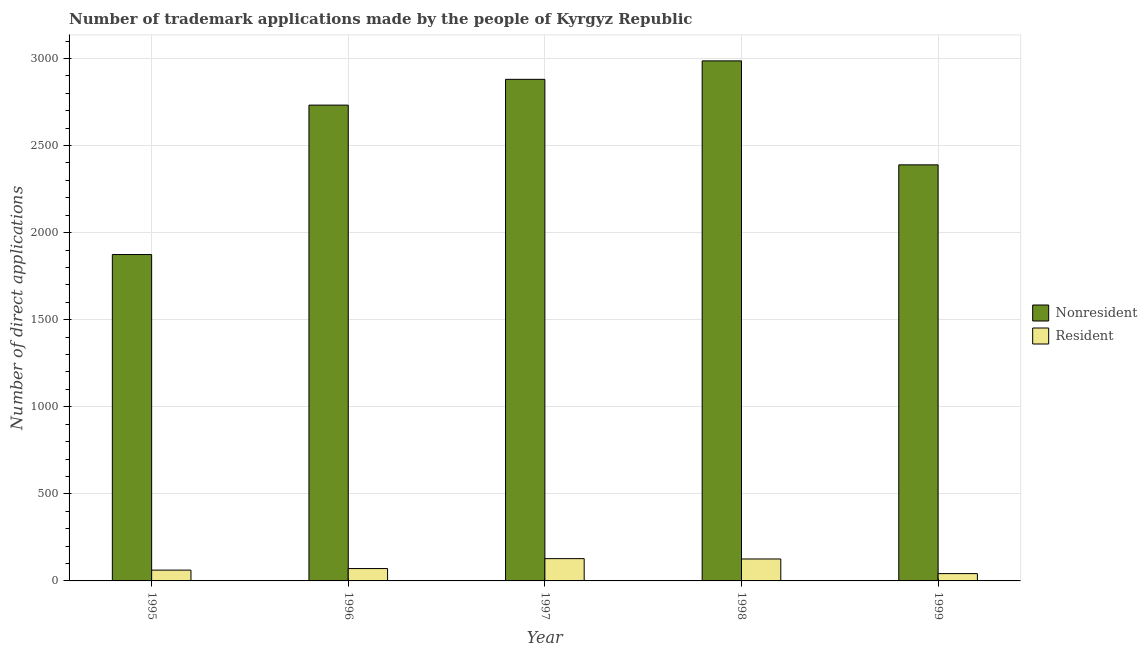Are the number of bars per tick equal to the number of legend labels?
Your answer should be compact. Yes. Are the number of bars on each tick of the X-axis equal?
Give a very brief answer. Yes. How many bars are there on the 2nd tick from the left?
Make the answer very short. 2. How many bars are there on the 2nd tick from the right?
Your answer should be very brief. 2. What is the label of the 5th group of bars from the left?
Give a very brief answer. 1999. What is the number of trademark applications made by residents in 1999?
Your answer should be compact. 42. Across all years, what is the maximum number of trademark applications made by residents?
Your answer should be compact. 128. Across all years, what is the minimum number of trademark applications made by non residents?
Offer a terse response. 1874. In which year was the number of trademark applications made by residents maximum?
Make the answer very short. 1997. In which year was the number of trademark applications made by non residents minimum?
Your answer should be very brief. 1995. What is the total number of trademark applications made by non residents in the graph?
Give a very brief answer. 1.29e+04. What is the difference between the number of trademark applications made by residents in 1995 and that in 1996?
Your response must be concise. -9. What is the difference between the number of trademark applications made by non residents in 1996 and the number of trademark applications made by residents in 1997?
Provide a succinct answer. -148. What is the average number of trademark applications made by non residents per year?
Offer a terse response. 2572.2. In how many years, is the number of trademark applications made by non residents greater than 200?
Offer a terse response. 5. What is the ratio of the number of trademark applications made by residents in 1997 to that in 1998?
Ensure brevity in your answer.  1.02. Is the number of trademark applications made by residents in 1995 less than that in 1998?
Your answer should be compact. Yes. Is the difference between the number of trademark applications made by residents in 1995 and 1998 greater than the difference between the number of trademark applications made by non residents in 1995 and 1998?
Keep it short and to the point. No. What is the difference between the highest and the second highest number of trademark applications made by non residents?
Offer a very short reply. 106. What is the difference between the highest and the lowest number of trademark applications made by non residents?
Ensure brevity in your answer.  1112. Is the sum of the number of trademark applications made by non residents in 1995 and 1997 greater than the maximum number of trademark applications made by residents across all years?
Keep it short and to the point. Yes. What does the 2nd bar from the left in 1996 represents?
Keep it short and to the point. Resident. What does the 2nd bar from the right in 1995 represents?
Your response must be concise. Nonresident. How many bars are there?
Provide a short and direct response. 10. What is the difference between two consecutive major ticks on the Y-axis?
Offer a very short reply. 500. Are the values on the major ticks of Y-axis written in scientific E-notation?
Provide a short and direct response. No. Does the graph contain any zero values?
Keep it short and to the point. No. Does the graph contain grids?
Make the answer very short. Yes. How many legend labels are there?
Offer a very short reply. 2. How are the legend labels stacked?
Make the answer very short. Vertical. What is the title of the graph?
Offer a terse response. Number of trademark applications made by the people of Kyrgyz Republic. What is the label or title of the Y-axis?
Give a very brief answer. Number of direct applications. What is the Number of direct applications in Nonresident in 1995?
Provide a succinct answer. 1874. What is the Number of direct applications in Nonresident in 1996?
Keep it short and to the point. 2732. What is the Number of direct applications of Nonresident in 1997?
Keep it short and to the point. 2880. What is the Number of direct applications of Resident in 1997?
Your answer should be compact. 128. What is the Number of direct applications of Nonresident in 1998?
Offer a very short reply. 2986. What is the Number of direct applications in Resident in 1998?
Keep it short and to the point. 126. What is the Number of direct applications of Nonresident in 1999?
Offer a very short reply. 2389. What is the Number of direct applications in Resident in 1999?
Make the answer very short. 42. Across all years, what is the maximum Number of direct applications of Nonresident?
Keep it short and to the point. 2986. Across all years, what is the maximum Number of direct applications in Resident?
Your response must be concise. 128. Across all years, what is the minimum Number of direct applications of Nonresident?
Your response must be concise. 1874. Across all years, what is the minimum Number of direct applications of Resident?
Ensure brevity in your answer.  42. What is the total Number of direct applications of Nonresident in the graph?
Your answer should be very brief. 1.29e+04. What is the total Number of direct applications of Resident in the graph?
Keep it short and to the point. 429. What is the difference between the Number of direct applications of Nonresident in 1995 and that in 1996?
Provide a succinct answer. -858. What is the difference between the Number of direct applications in Resident in 1995 and that in 1996?
Your response must be concise. -9. What is the difference between the Number of direct applications of Nonresident in 1995 and that in 1997?
Provide a succinct answer. -1006. What is the difference between the Number of direct applications in Resident in 1995 and that in 1997?
Ensure brevity in your answer.  -66. What is the difference between the Number of direct applications of Nonresident in 1995 and that in 1998?
Your answer should be compact. -1112. What is the difference between the Number of direct applications of Resident in 1995 and that in 1998?
Ensure brevity in your answer.  -64. What is the difference between the Number of direct applications of Nonresident in 1995 and that in 1999?
Give a very brief answer. -515. What is the difference between the Number of direct applications of Nonresident in 1996 and that in 1997?
Make the answer very short. -148. What is the difference between the Number of direct applications in Resident in 1996 and that in 1997?
Make the answer very short. -57. What is the difference between the Number of direct applications in Nonresident in 1996 and that in 1998?
Your response must be concise. -254. What is the difference between the Number of direct applications of Resident in 1996 and that in 1998?
Ensure brevity in your answer.  -55. What is the difference between the Number of direct applications in Nonresident in 1996 and that in 1999?
Your answer should be very brief. 343. What is the difference between the Number of direct applications in Nonresident in 1997 and that in 1998?
Make the answer very short. -106. What is the difference between the Number of direct applications of Resident in 1997 and that in 1998?
Make the answer very short. 2. What is the difference between the Number of direct applications in Nonresident in 1997 and that in 1999?
Ensure brevity in your answer.  491. What is the difference between the Number of direct applications in Resident in 1997 and that in 1999?
Your answer should be compact. 86. What is the difference between the Number of direct applications in Nonresident in 1998 and that in 1999?
Offer a terse response. 597. What is the difference between the Number of direct applications of Nonresident in 1995 and the Number of direct applications of Resident in 1996?
Your answer should be compact. 1803. What is the difference between the Number of direct applications of Nonresident in 1995 and the Number of direct applications of Resident in 1997?
Keep it short and to the point. 1746. What is the difference between the Number of direct applications of Nonresident in 1995 and the Number of direct applications of Resident in 1998?
Your response must be concise. 1748. What is the difference between the Number of direct applications of Nonresident in 1995 and the Number of direct applications of Resident in 1999?
Your answer should be very brief. 1832. What is the difference between the Number of direct applications of Nonresident in 1996 and the Number of direct applications of Resident in 1997?
Your response must be concise. 2604. What is the difference between the Number of direct applications in Nonresident in 1996 and the Number of direct applications in Resident in 1998?
Give a very brief answer. 2606. What is the difference between the Number of direct applications of Nonresident in 1996 and the Number of direct applications of Resident in 1999?
Provide a succinct answer. 2690. What is the difference between the Number of direct applications in Nonresident in 1997 and the Number of direct applications in Resident in 1998?
Your response must be concise. 2754. What is the difference between the Number of direct applications in Nonresident in 1997 and the Number of direct applications in Resident in 1999?
Provide a short and direct response. 2838. What is the difference between the Number of direct applications of Nonresident in 1998 and the Number of direct applications of Resident in 1999?
Keep it short and to the point. 2944. What is the average Number of direct applications of Nonresident per year?
Make the answer very short. 2572.2. What is the average Number of direct applications in Resident per year?
Your answer should be very brief. 85.8. In the year 1995, what is the difference between the Number of direct applications of Nonresident and Number of direct applications of Resident?
Offer a terse response. 1812. In the year 1996, what is the difference between the Number of direct applications in Nonresident and Number of direct applications in Resident?
Provide a succinct answer. 2661. In the year 1997, what is the difference between the Number of direct applications of Nonresident and Number of direct applications of Resident?
Provide a short and direct response. 2752. In the year 1998, what is the difference between the Number of direct applications of Nonresident and Number of direct applications of Resident?
Keep it short and to the point. 2860. In the year 1999, what is the difference between the Number of direct applications in Nonresident and Number of direct applications in Resident?
Offer a terse response. 2347. What is the ratio of the Number of direct applications of Nonresident in 1995 to that in 1996?
Make the answer very short. 0.69. What is the ratio of the Number of direct applications of Resident in 1995 to that in 1996?
Provide a succinct answer. 0.87. What is the ratio of the Number of direct applications of Nonresident in 1995 to that in 1997?
Offer a terse response. 0.65. What is the ratio of the Number of direct applications in Resident in 1995 to that in 1997?
Provide a short and direct response. 0.48. What is the ratio of the Number of direct applications of Nonresident in 1995 to that in 1998?
Your response must be concise. 0.63. What is the ratio of the Number of direct applications of Resident in 1995 to that in 1998?
Offer a very short reply. 0.49. What is the ratio of the Number of direct applications in Nonresident in 1995 to that in 1999?
Keep it short and to the point. 0.78. What is the ratio of the Number of direct applications in Resident in 1995 to that in 1999?
Your answer should be very brief. 1.48. What is the ratio of the Number of direct applications of Nonresident in 1996 to that in 1997?
Offer a terse response. 0.95. What is the ratio of the Number of direct applications of Resident in 1996 to that in 1997?
Make the answer very short. 0.55. What is the ratio of the Number of direct applications in Nonresident in 1996 to that in 1998?
Offer a very short reply. 0.91. What is the ratio of the Number of direct applications of Resident in 1996 to that in 1998?
Make the answer very short. 0.56. What is the ratio of the Number of direct applications of Nonresident in 1996 to that in 1999?
Your answer should be very brief. 1.14. What is the ratio of the Number of direct applications in Resident in 1996 to that in 1999?
Provide a short and direct response. 1.69. What is the ratio of the Number of direct applications of Nonresident in 1997 to that in 1998?
Your answer should be compact. 0.96. What is the ratio of the Number of direct applications of Resident in 1997 to that in 1998?
Keep it short and to the point. 1.02. What is the ratio of the Number of direct applications of Nonresident in 1997 to that in 1999?
Offer a terse response. 1.21. What is the ratio of the Number of direct applications of Resident in 1997 to that in 1999?
Give a very brief answer. 3.05. What is the ratio of the Number of direct applications of Nonresident in 1998 to that in 1999?
Keep it short and to the point. 1.25. What is the difference between the highest and the second highest Number of direct applications of Nonresident?
Provide a short and direct response. 106. What is the difference between the highest and the lowest Number of direct applications of Nonresident?
Make the answer very short. 1112. What is the difference between the highest and the lowest Number of direct applications in Resident?
Provide a succinct answer. 86. 